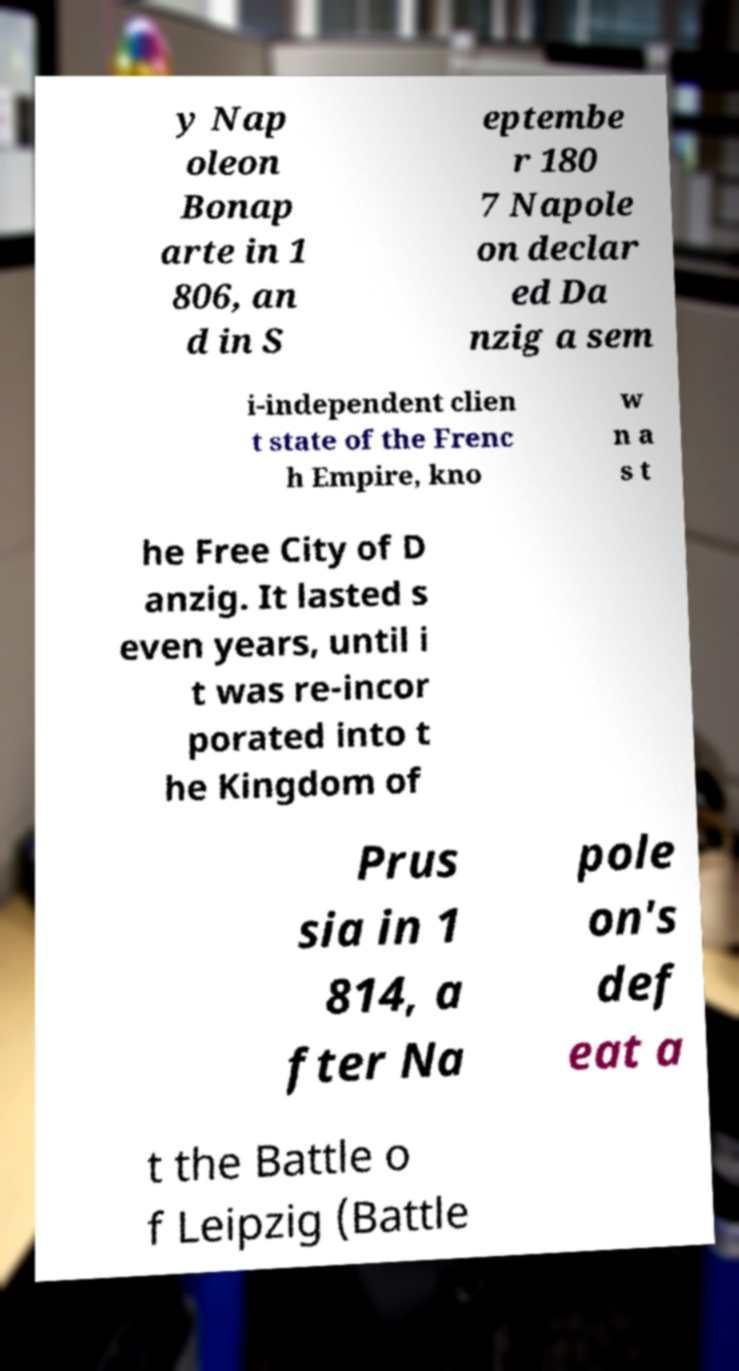There's text embedded in this image that I need extracted. Can you transcribe it verbatim? y Nap oleon Bonap arte in 1 806, an d in S eptembe r 180 7 Napole on declar ed Da nzig a sem i-independent clien t state of the Frenc h Empire, kno w n a s t he Free City of D anzig. It lasted s even years, until i t was re-incor porated into t he Kingdom of Prus sia in 1 814, a fter Na pole on's def eat a t the Battle o f Leipzig (Battle 